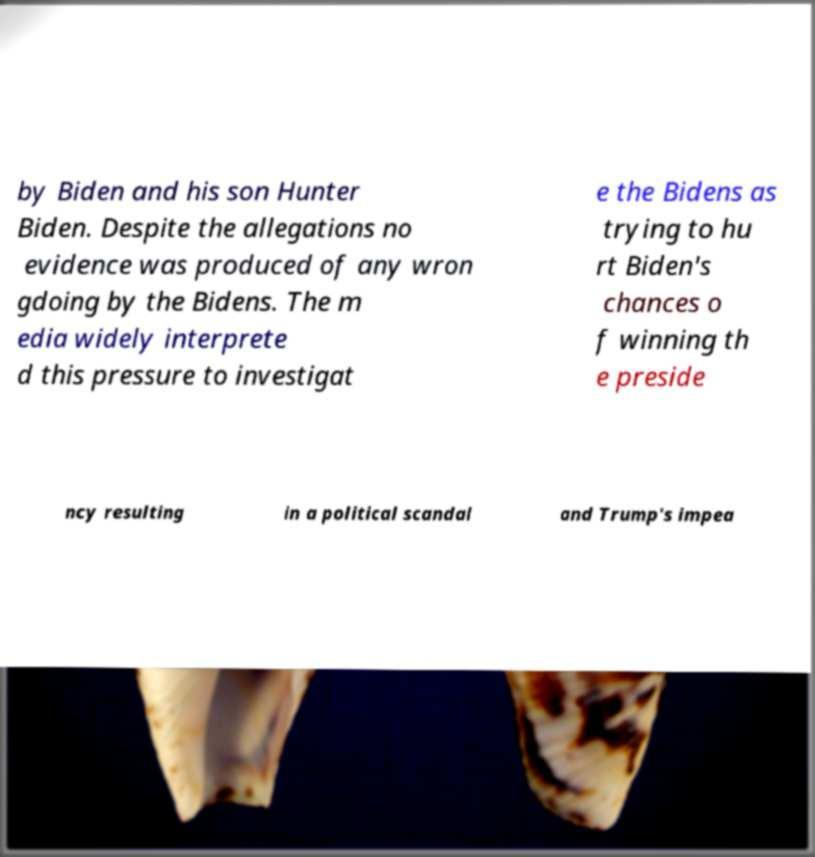What messages or text are displayed in this image? I need them in a readable, typed format. by Biden and his son Hunter Biden. Despite the allegations no evidence was produced of any wron gdoing by the Bidens. The m edia widely interprete d this pressure to investigat e the Bidens as trying to hu rt Biden's chances o f winning th e preside ncy resulting in a political scandal and Trump's impea 